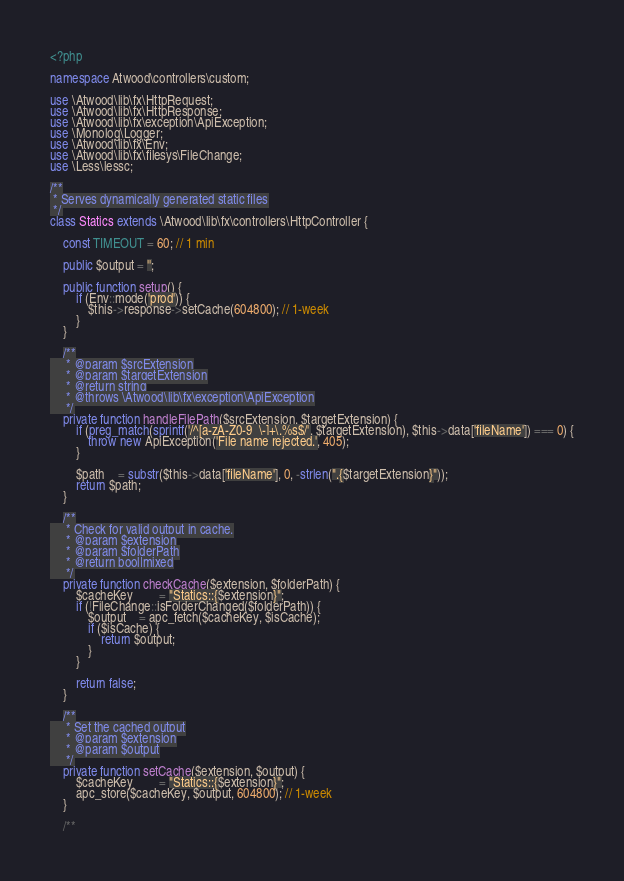<code> <loc_0><loc_0><loc_500><loc_500><_PHP_><?php

namespace Atwood\controllers\custom;

use \Atwood\lib\fx\HttpRequest;
use \Atwood\lib\fx\HttpResponse;
use \Atwood\lib\fx\exception\ApiException;
use \Monolog\Logger;
use \Atwood\lib\fx\Env;
use \Atwood\lib\fx\filesys\FileChange;
use \Less\lessc;

/**
 * Serves dynamically generated static files
 */
class Statics extends \Atwood\lib\fx\controllers\HttpController {

	const TIMEOUT = 60; // 1 min

	public $output = '';

	public function setup() {
		if (Env::mode('prod')) {
			$this->response->setCache(604800); // 1-week
		}
	}

	/**
	 * @param $srcExtension
	 * @param $targetExtension
	 * @return string
	 * @throws \Atwood\lib\fx\exception\ApiException
	 */
	private function handleFilePath($srcExtension, $targetExtension) {
		if (preg_match(sprintf('/^[a-zA-Z0-9_\-]+\.%s$/', $targetExtension), $this->data['fileName']) === 0) {
			throw new ApiException('File name rejected.', 405);
		}

		$path	= substr($this->data['fileName'], 0, -strlen(".{$targetExtension}"));
		return $path;
	}

	/**
	 * Check for valid output in cache.
	 * @param $extension
	 * @param $folderPath
	 * @return bool|mixed
	 */
	private function checkCache($extension, $folderPath) {
		$cacheKey		= "Statics::{$extension}";
		if (!FileChange::isFolderChanged($folderPath)) {
			$output	= apc_fetch($cacheKey, $isCache);
			if ($isCache) {
				return $output;
			}
		}

		return false;
	}

	/**
	 * Set the cached output
	 * @param $extension
	 * @param $output
	 */
	private function setCache($extension, $output) {
		$cacheKey		= "Statics::{$extension}";
		apc_store($cacheKey, $output, 604800); // 1-week
	}

	/**</code> 